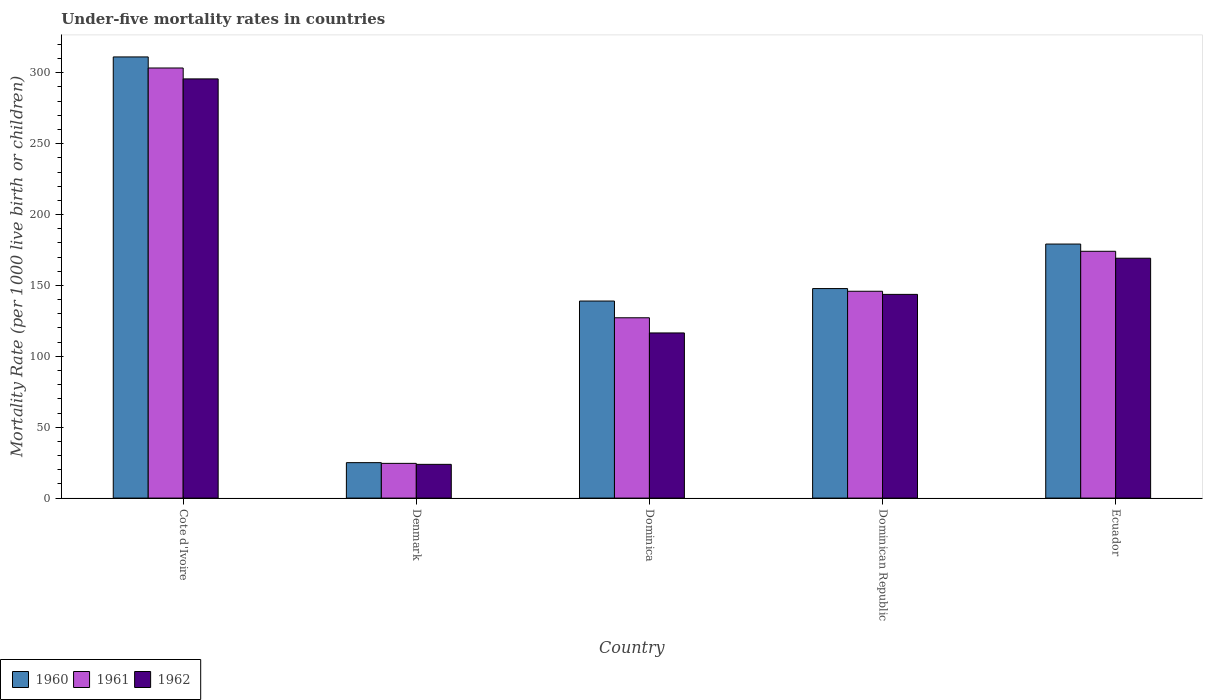How many different coloured bars are there?
Your answer should be very brief. 3. Are the number of bars per tick equal to the number of legend labels?
Give a very brief answer. Yes. Are the number of bars on each tick of the X-axis equal?
Provide a short and direct response. Yes. How many bars are there on the 1st tick from the left?
Your answer should be compact. 3. How many bars are there on the 4th tick from the right?
Your answer should be very brief. 3. What is the label of the 3rd group of bars from the left?
Your response must be concise. Dominica. What is the under-five mortality rate in 1962 in Denmark?
Make the answer very short. 23.8. Across all countries, what is the maximum under-five mortality rate in 1961?
Ensure brevity in your answer.  303.4. Across all countries, what is the minimum under-five mortality rate in 1962?
Provide a succinct answer. 23.8. In which country was the under-five mortality rate in 1962 maximum?
Offer a terse response. Cote d'Ivoire. In which country was the under-five mortality rate in 1961 minimum?
Keep it short and to the point. Denmark. What is the total under-five mortality rate in 1961 in the graph?
Provide a succinct answer. 775.1. What is the difference between the under-five mortality rate in 1961 in Cote d'Ivoire and that in Denmark?
Make the answer very short. 278.9. What is the difference between the under-five mortality rate in 1961 in Ecuador and the under-five mortality rate in 1962 in Dominica?
Make the answer very short. 57.6. What is the average under-five mortality rate in 1961 per country?
Your answer should be compact. 155.02. What is the difference between the under-five mortality rate of/in 1961 and under-five mortality rate of/in 1962 in Dominican Republic?
Offer a terse response. 2.2. In how many countries, is the under-five mortality rate in 1962 greater than 260?
Offer a very short reply. 1. What is the ratio of the under-five mortality rate in 1962 in Denmark to that in Dominican Republic?
Ensure brevity in your answer.  0.17. Is the under-five mortality rate in 1960 in Cote d'Ivoire less than that in Ecuador?
Provide a succinct answer. No. What is the difference between the highest and the second highest under-five mortality rate in 1961?
Your answer should be compact. -28.2. What is the difference between the highest and the lowest under-five mortality rate in 1962?
Provide a short and direct response. 271.9. Are all the bars in the graph horizontal?
Offer a very short reply. No. Does the graph contain grids?
Offer a very short reply. No. How many legend labels are there?
Ensure brevity in your answer.  3. How are the legend labels stacked?
Your response must be concise. Horizontal. What is the title of the graph?
Make the answer very short. Under-five mortality rates in countries. Does "2002" appear as one of the legend labels in the graph?
Your response must be concise. No. What is the label or title of the Y-axis?
Offer a terse response. Mortality Rate (per 1000 live birth or children). What is the Mortality Rate (per 1000 live birth or children) of 1960 in Cote d'Ivoire?
Your answer should be very brief. 311.2. What is the Mortality Rate (per 1000 live birth or children) of 1961 in Cote d'Ivoire?
Offer a very short reply. 303.4. What is the Mortality Rate (per 1000 live birth or children) of 1962 in Cote d'Ivoire?
Your response must be concise. 295.7. What is the Mortality Rate (per 1000 live birth or children) of 1961 in Denmark?
Offer a terse response. 24.5. What is the Mortality Rate (per 1000 live birth or children) of 1962 in Denmark?
Keep it short and to the point. 23.8. What is the Mortality Rate (per 1000 live birth or children) of 1960 in Dominica?
Keep it short and to the point. 139. What is the Mortality Rate (per 1000 live birth or children) of 1961 in Dominica?
Make the answer very short. 127.2. What is the Mortality Rate (per 1000 live birth or children) of 1962 in Dominica?
Provide a succinct answer. 116.5. What is the Mortality Rate (per 1000 live birth or children) of 1960 in Dominican Republic?
Offer a terse response. 147.8. What is the Mortality Rate (per 1000 live birth or children) of 1961 in Dominican Republic?
Provide a short and direct response. 145.9. What is the Mortality Rate (per 1000 live birth or children) of 1962 in Dominican Republic?
Keep it short and to the point. 143.7. What is the Mortality Rate (per 1000 live birth or children) of 1960 in Ecuador?
Provide a short and direct response. 179.2. What is the Mortality Rate (per 1000 live birth or children) in 1961 in Ecuador?
Provide a succinct answer. 174.1. What is the Mortality Rate (per 1000 live birth or children) in 1962 in Ecuador?
Offer a terse response. 169.2. Across all countries, what is the maximum Mortality Rate (per 1000 live birth or children) in 1960?
Offer a terse response. 311.2. Across all countries, what is the maximum Mortality Rate (per 1000 live birth or children) in 1961?
Keep it short and to the point. 303.4. Across all countries, what is the maximum Mortality Rate (per 1000 live birth or children) in 1962?
Your answer should be very brief. 295.7. Across all countries, what is the minimum Mortality Rate (per 1000 live birth or children) of 1962?
Your answer should be compact. 23.8. What is the total Mortality Rate (per 1000 live birth or children) of 1960 in the graph?
Your answer should be compact. 802.2. What is the total Mortality Rate (per 1000 live birth or children) of 1961 in the graph?
Your response must be concise. 775.1. What is the total Mortality Rate (per 1000 live birth or children) of 1962 in the graph?
Provide a succinct answer. 748.9. What is the difference between the Mortality Rate (per 1000 live birth or children) in 1960 in Cote d'Ivoire and that in Denmark?
Your response must be concise. 286.2. What is the difference between the Mortality Rate (per 1000 live birth or children) of 1961 in Cote d'Ivoire and that in Denmark?
Make the answer very short. 278.9. What is the difference between the Mortality Rate (per 1000 live birth or children) of 1962 in Cote d'Ivoire and that in Denmark?
Offer a terse response. 271.9. What is the difference between the Mortality Rate (per 1000 live birth or children) in 1960 in Cote d'Ivoire and that in Dominica?
Provide a short and direct response. 172.2. What is the difference between the Mortality Rate (per 1000 live birth or children) of 1961 in Cote d'Ivoire and that in Dominica?
Your response must be concise. 176.2. What is the difference between the Mortality Rate (per 1000 live birth or children) in 1962 in Cote d'Ivoire and that in Dominica?
Ensure brevity in your answer.  179.2. What is the difference between the Mortality Rate (per 1000 live birth or children) of 1960 in Cote d'Ivoire and that in Dominican Republic?
Provide a short and direct response. 163.4. What is the difference between the Mortality Rate (per 1000 live birth or children) of 1961 in Cote d'Ivoire and that in Dominican Republic?
Your answer should be compact. 157.5. What is the difference between the Mortality Rate (per 1000 live birth or children) in 1962 in Cote d'Ivoire and that in Dominican Republic?
Provide a short and direct response. 152. What is the difference between the Mortality Rate (per 1000 live birth or children) of 1960 in Cote d'Ivoire and that in Ecuador?
Provide a short and direct response. 132. What is the difference between the Mortality Rate (per 1000 live birth or children) in 1961 in Cote d'Ivoire and that in Ecuador?
Offer a very short reply. 129.3. What is the difference between the Mortality Rate (per 1000 live birth or children) in 1962 in Cote d'Ivoire and that in Ecuador?
Make the answer very short. 126.5. What is the difference between the Mortality Rate (per 1000 live birth or children) in 1960 in Denmark and that in Dominica?
Ensure brevity in your answer.  -114. What is the difference between the Mortality Rate (per 1000 live birth or children) in 1961 in Denmark and that in Dominica?
Offer a terse response. -102.7. What is the difference between the Mortality Rate (per 1000 live birth or children) in 1962 in Denmark and that in Dominica?
Keep it short and to the point. -92.7. What is the difference between the Mortality Rate (per 1000 live birth or children) of 1960 in Denmark and that in Dominican Republic?
Provide a succinct answer. -122.8. What is the difference between the Mortality Rate (per 1000 live birth or children) in 1961 in Denmark and that in Dominican Republic?
Give a very brief answer. -121.4. What is the difference between the Mortality Rate (per 1000 live birth or children) of 1962 in Denmark and that in Dominican Republic?
Provide a short and direct response. -119.9. What is the difference between the Mortality Rate (per 1000 live birth or children) in 1960 in Denmark and that in Ecuador?
Offer a terse response. -154.2. What is the difference between the Mortality Rate (per 1000 live birth or children) in 1961 in Denmark and that in Ecuador?
Ensure brevity in your answer.  -149.6. What is the difference between the Mortality Rate (per 1000 live birth or children) in 1962 in Denmark and that in Ecuador?
Offer a terse response. -145.4. What is the difference between the Mortality Rate (per 1000 live birth or children) in 1960 in Dominica and that in Dominican Republic?
Provide a short and direct response. -8.8. What is the difference between the Mortality Rate (per 1000 live birth or children) in 1961 in Dominica and that in Dominican Republic?
Provide a short and direct response. -18.7. What is the difference between the Mortality Rate (per 1000 live birth or children) of 1962 in Dominica and that in Dominican Republic?
Offer a very short reply. -27.2. What is the difference between the Mortality Rate (per 1000 live birth or children) of 1960 in Dominica and that in Ecuador?
Offer a terse response. -40.2. What is the difference between the Mortality Rate (per 1000 live birth or children) of 1961 in Dominica and that in Ecuador?
Provide a short and direct response. -46.9. What is the difference between the Mortality Rate (per 1000 live birth or children) of 1962 in Dominica and that in Ecuador?
Offer a very short reply. -52.7. What is the difference between the Mortality Rate (per 1000 live birth or children) in 1960 in Dominican Republic and that in Ecuador?
Keep it short and to the point. -31.4. What is the difference between the Mortality Rate (per 1000 live birth or children) of 1961 in Dominican Republic and that in Ecuador?
Offer a terse response. -28.2. What is the difference between the Mortality Rate (per 1000 live birth or children) in 1962 in Dominican Republic and that in Ecuador?
Provide a succinct answer. -25.5. What is the difference between the Mortality Rate (per 1000 live birth or children) of 1960 in Cote d'Ivoire and the Mortality Rate (per 1000 live birth or children) of 1961 in Denmark?
Offer a very short reply. 286.7. What is the difference between the Mortality Rate (per 1000 live birth or children) of 1960 in Cote d'Ivoire and the Mortality Rate (per 1000 live birth or children) of 1962 in Denmark?
Offer a very short reply. 287.4. What is the difference between the Mortality Rate (per 1000 live birth or children) in 1961 in Cote d'Ivoire and the Mortality Rate (per 1000 live birth or children) in 1962 in Denmark?
Your response must be concise. 279.6. What is the difference between the Mortality Rate (per 1000 live birth or children) in 1960 in Cote d'Ivoire and the Mortality Rate (per 1000 live birth or children) in 1961 in Dominica?
Keep it short and to the point. 184. What is the difference between the Mortality Rate (per 1000 live birth or children) in 1960 in Cote d'Ivoire and the Mortality Rate (per 1000 live birth or children) in 1962 in Dominica?
Ensure brevity in your answer.  194.7. What is the difference between the Mortality Rate (per 1000 live birth or children) in 1961 in Cote d'Ivoire and the Mortality Rate (per 1000 live birth or children) in 1962 in Dominica?
Offer a very short reply. 186.9. What is the difference between the Mortality Rate (per 1000 live birth or children) in 1960 in Cote d'Ivoire and the Mortality Rate (per 1000 live birth or children) in 1961 in Dominican Republic?
Your answer should be very brief. 165.3. What is the difference between the Mortality Rate (per 1000 live birth or children) in 1960 in Cote d'Ivoire and the Mortality Rate (per 1000 live birth or children) in 1962 in Dominican Republic?
Give a very brief answer. 167.5. What is the difference between the Mortality Rate (per 1000 live birth or children) in 1961 in Cote d'Ivoire and the Mortality Rate (per 1000 live birth or children) in 1962 in Dominican Republic?
Your answer should be compact. 159.7. What is the difference between the Mortality Rate (per 1000 live birth or children) in 1960 in Cote d'Ivoire and the Mortality Rate (per 1000 live birth or children) in 1961 in Ecuador?
Offer a very short reply. 137.1. What is the difference between the Mortality Rate (per 1000 live birth or children) in 1960 in Cote d'Ivoire and the Mortality Rate (per 1000 live birth or children) in 1962 in Ecuador?
Your answer should be very brief. 142. What is the difference between the Mortality Rate (per 1000 live birth or children) in 1961 in Cote d'Ivoire and the Mortality Rate (per 1000 live birth or children) in 1962 in Ecuador?
Provide a short and direct response. 134.2. What is the difference between the Mortality Rate (per 1000 live birth or children) in 1960 in Denmark and the Mortality Rate (per 1000 live birth or children) in 1961 in Dominica?
Ensure brevity in your answer.  -102.2. What is the difference between the Mortality Rate (per 1000 live birth or children) of 1960 in Denmark and the Mortality Rate (per 1000 live birth or children) of 1962 in Dominica?
Provide a succinct answer. -91.5. What is the difference between the Mortality Rate (per 1000 live birth or children) in 1961 in Denmark and the Mortality Rate (per 1000 live birth or children) in 1962 in Dominica?
Offer a very short reply. -92. What is the difference between the Mortality Rate (per 1000 live birth or children) of 1960 in Denmark and the Mortality Rate (per 1000 live birth or children) of 1961 in Dominican Republic?
Offer a terse response. -120.9. What is the difference between the Mortality Rate (per 1000 live birth or children) in 1960 in Denmark and the Mortality Rate (per 1000 live birth or children) in 1962 in Dominican Republic?
Make the answer very short. -118.7. What is the difference between the Mortality Rate (per 1000 live birth or children) of 1961 in Denmark and the Mortality Rate (per 1000 live birth or children) of 1962 in Dominican Republic?
Keep it short and to the point. -119.2. What is the difference between the Mortality Rate (per 1000 live birth or children) of 1960 in Denmark and the Mortality Rate (per 1000 live birth or children) of 1961 in Ecuador?
Offer a terse response. -149.1. What is the difference between the Mortality Rate (per 1000 live birth or children) in 1960 in Denmark and the Mortality Rate (per 1000 live birth or children) in 1962 in Ecuador?
Ensure brevity in your answer.  -144.2. What is the difference between the Mortality Rate (per 1000 live birth or children) of 1961 in Denmark and the Mortality Rate (per 1000 live birth or children) of 1962 in Ecuador?
Provide a succinct answer. -144.7. What is the difference between the Mortality Rate (per 1000 live birth or children) of 1960 in Dominica and the Mortality Rate (per 1000 live birth or children) of 1961 in Dominican Republic?
Ensure brevity in your answer.  -6.9. What is the difference between the Mortality Rate (per 1000 live birth or children) in 1961 in Dominica and the Mortality Rate (per 1000 live birth or children) in 1962 in Dominican Republic?
Offer a very short reply. -16.5. What is the difference between the Mortality Rate (per 1000 live birth or children) in 1960 in Dominica and the Mortality Rate (per 1000 live birth or children) in 1961 in Ecuador?
Ensure brevity in your answer.  -35.1. What is the difference between the Mortality Rate (per 1000 live birth or children) of 1960 in Dominica and the Mortality Rate (per 1000 live birth or children) of 1962 in Ecuador?
Provide a short and direct response. -30.2. What is the difference between the Mortality Rate (per 1000 live birth or children) of 1961 in Dominica and the Mortality Rate (per 1000 live birth or children) of 1962 in Ecuador?
Offer a very short reply. -42. What is the difference between the Mortality Rate (per 1000 live birth or children) in 1960 in Dominican Republic and the Mortality Rate (per 1000 live birth or children) in 1961 in Ecuador?
Offer a terse response. -26.3. What is the difference between the Mortality Rate (per 1000 live birth or children) in 1960 in Dominican Republic and the Mortality Rate (per 1000 live birth or children) in 1962 in Ecuador?
Offer a terse response. -21.4. What is the difference between the Mortality Rate (per 1000 live birth or children) in 1961 in Dominican Republic and the Mortality Rate (per 1000 live birth or children) in 1962 in Ecuador?
Provide a succinct answer. -23.3. What is the average Mortality Rate (per 1000 live birth or children) in 1960 per country?
Offer a very short reply. 160.44. What is the average Mortality Rate (per 1000 live birth or children) in 1961 per country?
Offer a very short reply. 155.02. What is the average Mortality Rate (per 1000 live birth or children) in 1962 per country?
Give a very brief answer. 149.78. What is the difference between the Mortality Rate (per 1000 live birth or children) in 1960 and Mortality Rate (per 1000 live birth or children) in 1961 in Cote d'Ivoire?
Make the answer very short. 7.8. What is the difference between the Mortality Rate (per 1000 live birth or children) in 1960 and Mortality Rate (per 1000 live birth or children) in 1962 in Cote d'Ivoire?
Offer a very short reply. 15.5. What is the difference between the Mortality Rate (per 1000 live birth or children) of 1960 and Mortality Rate (per 1000 live birth or children) of 1961 in Dominica?
Your response must be concise. 11.8. What is the difference between the Mortality Rate (per 1000 live birth or children) of 1960 and Mortality Rate (per 1000 live birth or children) of 1962 in Dominica?
Make the answer very short. 22.5. What is the difference between the Mortality Rate (per 1000 live birth or children) of 1960 and Mortality Rate (per 1000 live birth or children) of 1962 in Dominican Republic?
Provide a short and direct response. 4.1. What is the difference between the Mortality Rate (per 1000 live birth or children) of 1960 and Mortality Rate (per 1000 live birth or children) of 1961 in Ecuador?
Provide a succinct answer. 5.1. What is the difference between the Mortality Rate (per 1000 live birth or children) in 1961 and Mortality Rate (per 1000 live birth or children) in 1962 in Ecuador?
Offer a very short reply. 4.9. What is the ratio of the Mortality Rate (per 1000 live birth or children) in 1960 in Cote d'Ivoire to that in Denmark?
Your response must be concise. 12.45. What is the ratio of the Mortality Rate (per 1000 live birth or children) in 1961 in Cote d'Ivoire to that in Denmark?
Your answer should be very brief. 12.38. What is the ratio of the Mortality Rate (per 1000 live birth or children) in 1962 in Cote d'Ivoire to that in Denmark?
Ensure brevity in your answer.  12.42. What is the ratio of the Mortality Rate (per 1000 live birth or children) in 1960 in Cote d'Ivoire to that in Dominica?
Make the answer very short. 2.24. What is the ratio of the Mortality Rate (per 1000 live birth or children) of 1961 in Cote d'Ivoire to that in Dominica?
Your answer should be compact. 2.39. What is the ratio of the Mortality Rate (per 1000 live birth or children) of 1962 in Cote d'Ivoire to that in Dominica?
Give a very brief answer. 2.54. What is the ratio of the Mortality Rate (per 1000 live birth or children) in 1960 in Cote d'Ivoire to that in Dominican Republic?
Give a very brief answer. 2.11. What is the ratio of the Mortality Rate (per 1000 live birth or children) of 1961 in Cote d'Ivoire to that in Dominican Republic?
Provide a succinct answer. 2.08. What is the ratio of the Mortality Rate (per 1000 live birth or children) of 1962 in Cote d'Ivoire to that in Dominican Republic?
Your answer should be compact. 2.06. What is the ratio of the Mortality Rate (per 1000 live birth or children) in 1960 in Cote d'Ivoire to that in Ecuador?
Your answer should be compact. 1.74. What is the ratio of the Mortality Rate (per 1000 live birth or children) in 1961 in Cote d'Ivoire to that in Ecuador?
Your answer should be compact. 1.74. What is the ratio of the Mortality Rate (per 1000 live birth or children) of 1962 in Cote d'Ivoire to that in Ecuador?
Provide a succinct answer. 1.75. What is the ratio of the Mortality Rate (per 1000 live birth or children) in 1960 in Denmark to that in Dominica?
Make the answer very short. 0.18. What is the ratio of the Mortality Rate (per 1000 live birth or children) in 1961 in Denmark to that in Dominica?
Provide a short and direct response. 0.19. What is the ratio of the Mortality Rate (per 1000 live birth or children) in 1962 in Denmark to that in Dominica?
Offer a very short reply. 0.2. What is the ratio of the Mortality Rate (per 1000 live birth or children) in 1960 in Denmark to that in Dominican Republic?
Your answer should be compact. 0.17. What is the ratio of the Mortality Rate (per 1000 live birth or children) of 1961 in Denmark to that in Dominican Republic?
Provide a succinct answer. 0.17. What is the ratio of the Mortality Rate (per 1000 live birth or children) in 1962 in Denmark to that in Dominican Republic?
Make the answer very short. 0.17. What is the ratio of the Mortality Rate (per 1000 live birth or children) in 1960 in Denmark to that in Ecuador?
Offer a very short reply. 0.14. What is the ratio of the Mortality Rate (per 1000 live birth or children) of 1961 in Denmark to that in Ecuador?
Offer a terse response. 0.14. What is the ratio of the Mortality Rate (per 1000 live birth or children) of 1962 in Denmark to that in Ecuador?
Offer a very short reply. 0.14. What is the ratio of the Mortality Rate (per 1000 live birth or children) of 1960 in Dominica to that in Dominican Republic?
Make the answer very short. 0.94. What is the ratio of the Mortality Rate (per 1000 live birth or children) of 1961 in Dominica to that in Dominican Republic?
Your answer should be compact. 0.87. What is the ratio of the Mortality Rate (per 1000 live birth or children) of 1962 in Dominica to that in Dominican Republic?
Give a very brief answer. 0.81. What is the ratio of the Mortality Rate (per 1000 live birth or children) in 1960 in Dominica to that in Ecuador?
Ensure brevity in your answer.  0.78. What is the ratio of the Mortality Rate (per 1000 live birth or children) of 1961 in Dominica to that in Ecuador?
Keep it short and to the point. 0.73. What is the ratio of the Mortality Rate (per 1000 live birth or children) of 1962 in Dominica to that in Ecuador?
Provide a short and direct response. 0.69. What is the ratio of the Mortality Rate (per 1000 live birth or children) of 1960 in Dominican Republic to that in Ecuador?
Offer a very short reply. 0.82. What is the ratio of the Mortality Rate (per 1000 live birth or children) of 1961 in Dominican Republic to that in Ecuador?
Your answer should be very brief. 0.84. What is the ratio of the Mortality Rate (per 1000 live birth or children) of 1962 in Dominican Republic to that in Ecuador?
Provide a succinct answer. 0.85. What is the difference between the highest and the second highest Mortality Rate (per 1000 live birth or children) in 1960?
Offer a very short reply. 132. What is the difference between the highest and the second highest Mortality Rate (per 1000 live birth or children) in 1961?
Offer a terse response. 129.3. What is the difference between the highest and the second highest Mortality Rate (per 1000 live birth or children) of 1962?
Provide a short and direct response. 126.5. What is the difference between the highest and the lowest Mortality Rate (per 1000 live birth or children) in 1960?
Your answer should be very brief. 286.2. What is the difference between the highest and the lowest Mortality Rate (per 1000 live birth or children) in 1961?
Your answer should be compact. 278.9. What is the difference between the highest and the lowest Mortality Rate (per 1000 live birth or children) in 1962?
Provide a short and direct response. 271.9. 